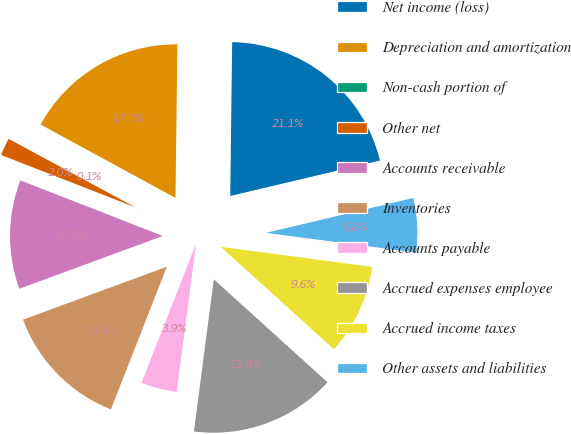<chart> <loc_0><loc_0><loc_500><loc_500><pie_chart><fcel>Net income (loss)<fcel>Depreciation and amortization<fcel>Non-cash portion of<fcel>Other net<fcel>Accounts receivable<fcel>Inventories<fcel>Accounts payable<fcel>Accrued expenses employee<fcel>Accrued income taxes<fcel>Other assets and liabilities<nl><fcel>21.1%<fcel>17.27%<fcel>0.05%<fcel>1.96%<fcel>11.53%<fcel>13.44%<fcel>3.88%<fcel>15.36%<fcel>9.62%<fcel>5.79%<nl></chart> 